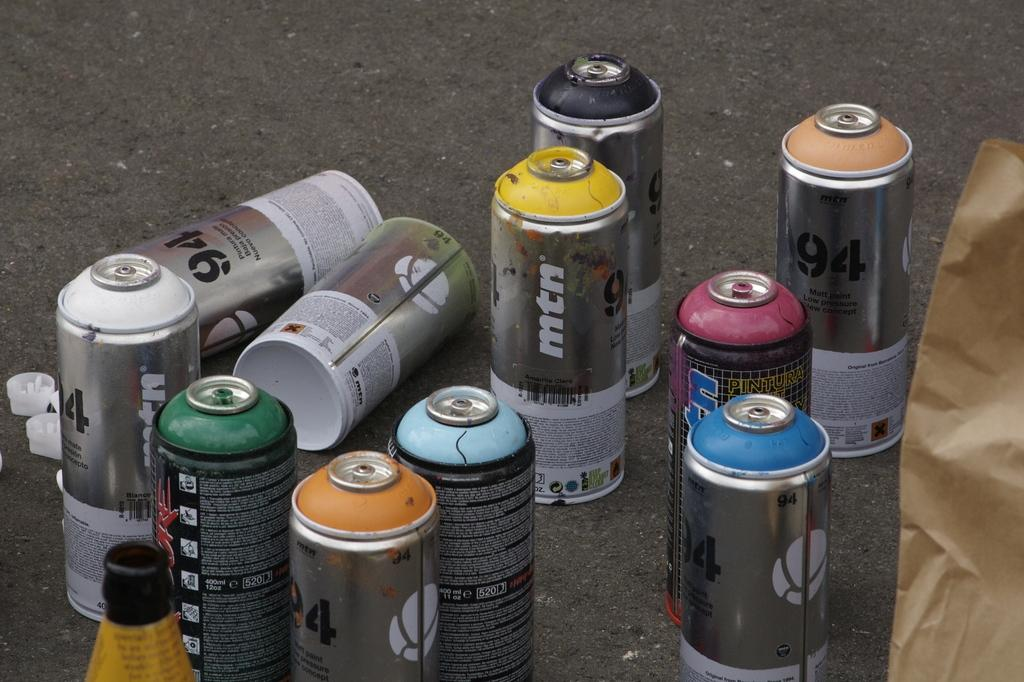What objects are on the path in the image? There are bottles on the path in the image. What can be seen on the right side of the image? There is a cover on the right side of the image. What type of trail can be seen in the image? There is no trail visible in the image; it only shows bottles on a path and a cover on the right side. 